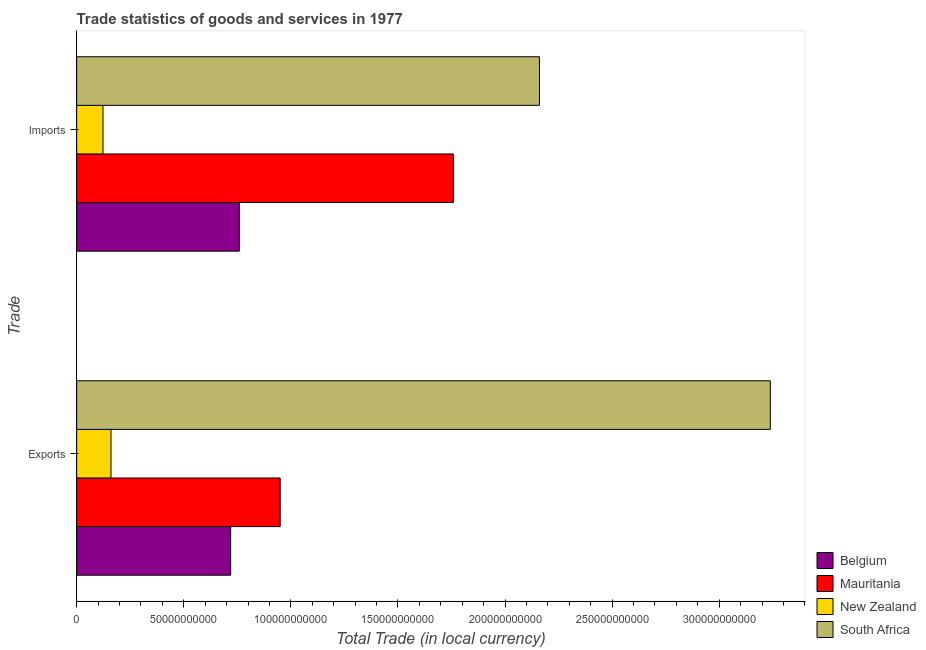Are the number of bars per tick equal to the number of legend labels?
Your answer should be very brief. Yes. How many bars are there on the 2nd tick from the bottom?
Offer a terse response. 4. What is the label of the 1st group of bars from the top?
Make the answer very short. Imports. What is the imports of goods and services in New Zealand?
Provide a succinct answer. 1.23e+1. Across all countries, what is the maximum imports of goods and services?
Offer a very short reply. 2.16e+11. Across all countries, what is the minimum export of goods and services?
Offer a terse response. 1.60e+1. In which country was the export of goods and services maximum?
Your answer should be compact. South Africa. In which country was the export of goods and services minimum?
Your answer should be compact. New Zealand. What is the total imports of goods and services in the graph?
Give a very brief answer. 4.80e+11. What is the difference between the imports of goods and services in Mauritania and that in New Zealand?
Keep it short and to the point. 1.64e+11. What is the difference between the export of goods and services in Belgium and the imports of goods and services in Mauritania?
Your answer should be compact. -1.04e+11. What is the average export of goods and services per country?
Offer a terse response. 1.27e+11. What is the difference between the imports of goods and services and export of goods and services in Mauritania?
Your answer should be very brief. 8.09e+1. What is the ratio of the imports of goods and services in Belgium to that in South Africa?
Give a very brief answer. 0.35. What does the 3rd bar from the top in Exports represents?
Make the answer very short. Mauritania. What does the 3rd bar from the bottom in Exports represents?
Give a very brief answer. New Zealand. How many countries are there in the graph?
Make the answer very short. 4. What is the difference between two consecutive major ticks on the X-axis?
Offer a very short reply. 5.00e+1. Are the values on the major ticks of X-axis written in scientific E-notation?
Ensure brevity in your answer.  No. Does the graph contain grids?
Provide a succinct answer. No. Where does the legend appear in the graph?
Provide a succinct answer. Bottom right. What is the title of the graph?
Offer a terse response. Trade statistics of goods and services in 1977. Does "Lesotho" appear as one of the legend labels in the graph?
Give a very brief answer. No. What is the label or title of the X-axis?
Give a very brief answer. Total Trade (in local currency). What is the label or title of the Y-axis?
Your response must be concise. Trade. What is the Total Trade (in local currency) in Belgium in Exports?
Your response must be concise. 7.19e+1. What is the Total Trade (in local currency) of Mauritania in Exports?
Ensure brevity in your answer.  9.50e+1. What is the Total Trade (in local currency) of New Zealand in Exports?
Provide a short and direct response. 1.60e+1. What is the Total Trade (in local currency) of South Africa in Exports?
Give a very brief answer. 3.24e+11. What is the Total Trade (in local currency) in Belgium in Imports?
Your response must be concise. 7.59e+1. What is the Total Trade (in local currency) of Mauritania in Imports?
Your answer should be very brief. 1.76e+11. What is the Total Trade (in local currency) in New Zealand in Imports?
Make the answer very short. 1.23e+1. What is the Total Trade (in local currency) of South Africa in Imports?
Provide a succinct answer. 2.16e+11. Across all Trade, what is the maximum Total Trade (in local currency) of Belgium?
Offer a very short reply. 7.59e+1. Across all Trade, what is the maximum Total Trade (in local currency) of Mauritania?
Your answer should be very brief. 1.76e+11. Across all Trade, what is the maximum Total Trade (in local currency) in New Zealand?
Make the answer very short. 1.60e+1. Across all Trade, what is the maximum Total Trade (in local currency) of South Africa?
Ensure brevity in your answer.  3.24e+11. Across all Trade, what is the minimum Total Trade (in local currency) of Belgium?
Give a very brief answer. 7.19e+1. Across all Trade, what is the minimum Total Trade (in local currency) in Mauritania?
Provide a succinct answer. 9.50e+1. Across all Trade, what is the minimum Total Trade (in local currency) in New Zealand?
Provide a short and direct response. 1.23e+1. Across all Trade, what is the minimum Total Trade (in local currency) of South Africa?
Provide a succinct answer. 2.16e+11. What is the total Total Trade (in local currency) of Belgium in the graph?
Your answer should be compact. 1.48e+11. What is the total Total Trade (in local currency) of Mauritania in the graph?
Provide a short and direct response. 2.71e+11. What is the total Total Trade (in local currency) of New Zealand in the graph?
Your answer should be compact. 2.83e+1. What is the total Total Trade (in local currency) of South Africa in the graph?
Provide a succinct answer. 5.40e+11. What is the difference between the Total Trade (in local currency) of Belgium in Exports and that in Imports?
Ensure brevity in your answer.  -4.03e+09. What is the difference between the Total Trade (in local currency) of Mauritania in Exports and that in Imports?
Offer a terse response. -8.09e+1. What is the difference between the Total Trade (in local currency) of New Zealand in Exports and that in Imports?
Your response must be concise. 3.74e+09. What is the difference between the Total Trade (in local currency) of South Africa in Exports and that in Imports?
Offer a terse response. 1.08e+11. What is the difference between the Total Trade (in local currency) of Belgium in Exports and the Total Trade (in local currency) of Mauritania in Imports?
Your response must be concise. -1.04e+11. What is the difference between the Total Trade (in local currency) in Belgium in Exports and the Total Trade (in local currency) in New Zealand in Imports?
Give a very brief answer. 5.96e+1. What is the difference between the Total Trade (in local currency) in Belgium in Exports and the Total Trade (in local currency) in South Africa in Imports?
Offer a very short reply. -1.44e+11. What is the difference between the Total Trade (in local currency) of Mauritania in Exports and the Total Trade (in local currency) of New Zealand in Imports?
Your answer should be compact. 8.27e+1. What is the difference between the Total Trade (in local currency) in Mauritania in Exports and the Total Trade (in local currency) in South Africa in Imports?
Make the answer very short. -1.21e+11. What is the difference between the Total Trade (in local currency) of New Zealand in Exports and the Total Trade (in local currency) of South Africa in Imports?
Your answer should be compact. -2.00e+11. What is the average Total Trade (in local currency) in Belgium per Trade?
Provide a short and direct response. 7.39e+1. What is the average Total Trade (in local currency) in Mauritania per Trade?
Keep it short and to the point. 1.35e+11. What is the average Total Trade (in local currency) in New Zealand per Trade?
Provide a short and direct response. 1.42e+1. What is the average Total Trade (in local currency) of South Africa per Trade?
Provide a succinct answer. 2.70e+11. What is the difference between the Total Trade (in local currency) of Belgium and Total Trade (in local currency) of Mauritania in Exports?
Ensure brevity in your answer.  -2.31e+1. What is the difference between the Total Trade (in local currency) of Belgium and Total Trade (in local currency) of New Zealand in Exports?
Make the answer very short. 5.59e+1. What is the difference between the Total Trade (in local currency) of Belgium and Total Trade (in local currency) of South Africa in Exports?
Your answer should be compact. -2.52e+11. What is the difference between the Total Trade (in local currency) in Mauritania and Total Trade (in local currency) in New Zealand in Exports?
Offer a very short reply. 7.90e+1. What is the difference between the Total Trade (in local currency) of Mauritania and Total Trade (in local currency) of South Africa in Exports?
Provide a short and direct response. -2.29e+11. What is the difference between the Total Trade (in local currency) in New Zealand and Total Trade (in local currency) in South Africa in Exports?
Ensure brevity in your answer.  -3.08e+11. What is the difference between the Total Trade (in local currency) of Belgium and Total Trade (in local currency) of Mauritania in Imports?
Keep it short and to the point. -1.00e+11. What is the difference between the Total Trade (in local currency) of Belgium and Total Trade (in local currency) of New Zealand in Imports?
Ensure brevity in your answer.  6.36e+1. What is the difference between the Total Trade (in local currency) in Belgium and Total Trade (in local currency) in South Africa in Imports?
Your answer should be compact. -1.40e+11. What is the difference between the Total Trade (in local currency) in Mauritania and Total Trade (in local currency) in New Zealand in Imports?
Your answer should be very brief. 1.64e+11. What is the difference between the Total Trade (in local currency) of Mauritania and Total Trade (in local currency) of South Africa in Imports?
Offer a terse response. -4.02e+1. What is the difference between the Total Trade (in local currency) in New Zealand and Total Trade (in local currency) in South Africa in Imports?
Keep it short and to the point. -2.04e+11. What is the ratio of the Total Trade (in local currency) in Belgium in Exports to that in Imports?
Give a very brief answer. 0.95. What is the ratio of the Total Trade (in local currency) of Mauritania in Exports to that in Imports?
Your answer should be very brief. 0.54. What is the ratio of the Total Trade (in local currency) of New Zealand in Exports to that in Imports?
Offer a very short reply. 1.3. What is the ratio of the Total Trade (in local currency) in South Africa in Exports to that in Imports?
Provide a succinct answer. 1.5. What is the difference between the highest and the second highest Total Trade (in local currency) in Belgium?
Offer a very short reply. 4.03e+09. What is the difference between the highest and the second highest Total Trade (in local currency) in Mauritania?
Offer a terse response. 8.09e+1. What is the difference between the highest and the second highest Total Trade (in local currency) of New Zealand?
Your answer should be compact. 3.74e+09. What is the difference between the highest and the second highest Total Trade (in local currency) in South Africa?
Keep it short and to the point. 1.08e+11. What is the difference between the highest and the lowest Total Trade (in local currency) in Belgium?
Your response must be concise. 4.03e+09. What is the difference between the highest and the lowest Total Trade (in local currency) in Mauritania?
Offer a very short reply. 8.09e+1. What is the difference between the highest and the lowest Total Trade (in local currency) in New Zealand?
Your response must be concise. 3.74e+09. What is the difference between the highest and the lowest Total Trade (in local currency) of South Africa?
Provide a succinct answer. 1.08e+11. 